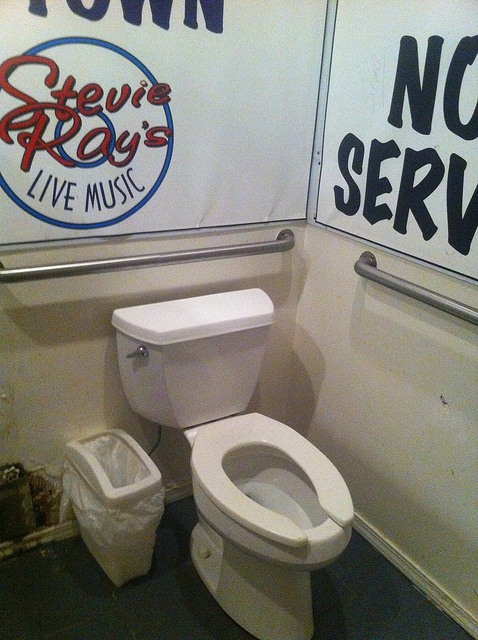Describe the objects in this image and their specific colors. I can see a toilet in lightgray, gray, darkgray, and darkgreen tones in this image. 